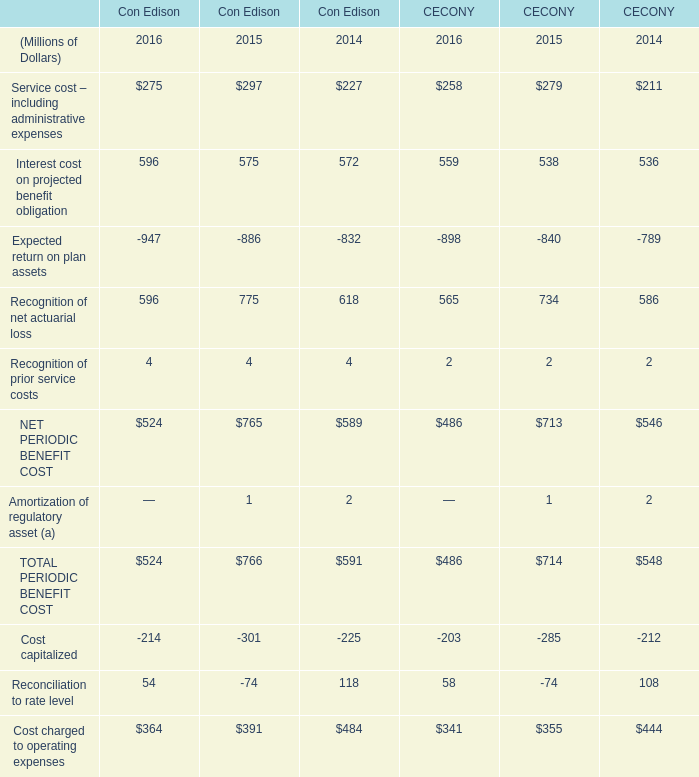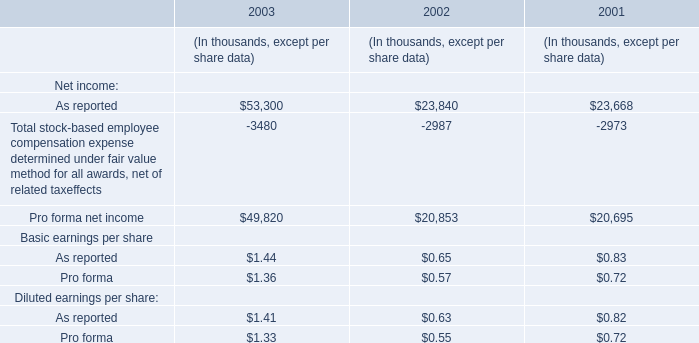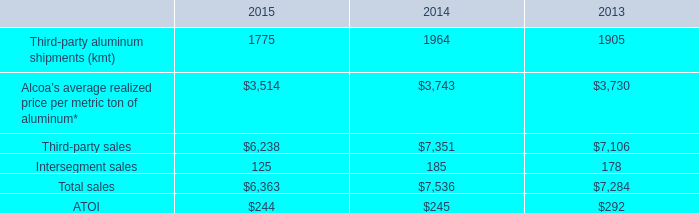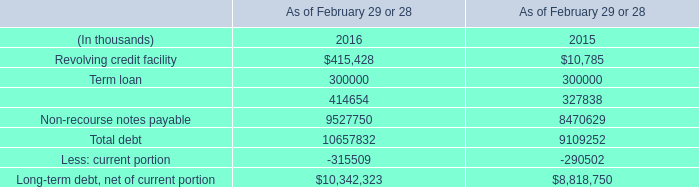Does the value of Recognition of net actuarial loss for Con Edison in 2016 greater than that in 2015? 
Answer: No. 